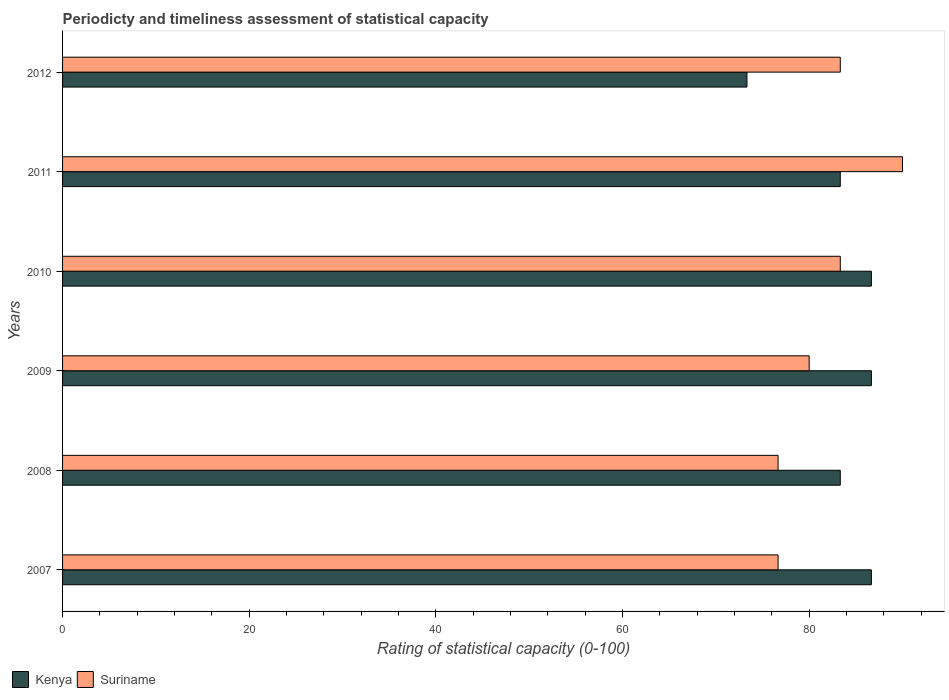How many different coloured bars are there?
Ensure brevity in your answer.  2. How many groups of bars are there?
Your answer should be compact. 6. Are the number of bars per tick equal to the number of legend labels?
Give a very brief answer. Yes. How many bars are there on the 5th tick from the top?
Your response must be concise. 2. In how many cases, is the number of bars for a given year not equal to the number of legend labels?
Your answer should be very brief. 0. What is the rating of statistical capacity in Suriname in 2009?
Your response must be concise. 80. Across all years, what is the maximum rating of statistical capacity in Kenya?
Ensure brevity in your answer.  86.67. Across all years, what is the minimum rating of statistical capacity in Kenya?
Offer a terse response. 73.33. In which year was the rating of statistical capacity in Suriname maximum?
Your answer should be very brief. 2011. What is the total rating of statistical capacity in Suriname in the graph?
Your answer should be very brief. 490. What is the difference between the rating of statistical capacity in Kenya in 2010 and that in 2012?
Keep it short and to the point. 13.33. What is the difference between the rating of statistical capacity in Kenya in 2010 and the rating of statistical capacity in Suriname in 2007?
Ensure brevity in your answer.  10. What is the average rating of statistical capacity in Suriname per year?
Your response must be concise. 81.67. In the year 2012, what is the difference between the rating of statistical capacity in Suriname and rating of statistical capacity in Kenya?
Keep it short and to the point. 10. What is the ratio of the rating of statistical capacity in Kenya in 2009 to that in 2012?
Your response must be concise. 1.18. Is the rating of statistical capacity in Kenya in 2008 less than that in 2011?
Give a very brief answer. No. Is the difference between the rating of statistical capacity in Suriname in 2009 and 2011 greater than the difference between the rating of statistical capacity in Kenya in 2009 and 2011?
Make the answer very short. No. What is the difference between the highest and the second highest rating of statistical capacity in Suriname?
Make the answer very short. 6.67. What is the difference between the highest and the lowest rating of statistical capacity in Kenya?
Provide a short and direct response. 13.33. Is the sum of the rating of statistical capacity in Suriname in 2009 and 2010 greater than the maximum rating of statistical capacity in Kenya across all years?
Provide a succinct answer. Yes. What does the 2nd bar from the top in 2012 represents?
Your response must be concise. Kenya. What does the 2nd bar from the bottom in 2010 represents?
Provide a succinct answer. Suriname. Are all the bars in the graph horizontal?
Offer a terse response. Yes. How many years are there in the graph?
Keep it short and to the point. 6. Does the graph contain any zero values?
Keep it short and to the point. No. Does the graph contain grids?
Keep it short and to the point. No. Where does the legend appear in the graph?
Offer a very short reply. Bottom left. How are the legend labels stacked?
Provide a succinct answer. Horizontal. What is the title of the graph?
Give a very brief answer. Periodicty and timeliness assessment of statistical capacity. Does "Serbia" appear as one of the legend labels in the graph?
Ensure brevity in your answer.  No. What is the label or title of the X-axis?
Give a very brief answer. Rating of statistical capacity (0-100). What is the label or title of the Y-axis?
Your answer should be very brief. Years. What is the Rating of statistical capacity (0-100) of Kenya in 2007?
Ensure brevity in your answer.  86.67. What is the Rating of statistical capacity (0-100) in Suriname in 2007?
Your response must be concise. 76.67. What is the Rating of statistical capacity (0-100) in Kenya in 2008?
Your answer should be very brief. 83.33. What is the Rating of statistical capacity (0-100) of Suriname in 2008?
Offer a terse response. 76.67. What is the Rating of statistical capacity (0-100) of Kenya in 2009?
Provide a short and direct response. 86.67. What is the Rating of statistical capacity (0-100) in Suriname in 2009?
Your answer should be very brief. 80. What is the Rating of statistical capacity (0-100) of Kenya in 2010?
Give a very brief answer. 86.67. What is the Rating of statistical capacity (0-100) in Suriname in 2010?
Make the answer very short. 83.33. What is the Rating of statistical capacity (0-100) of Kenya in 2011?
Provide a short and direct response. 83.33. What is the Rating of statistical capacity (0-100) of Suriname in 2011?
Ensure brevity in your answer.  90. What is the Rating of statistical capacity (0-100) in Kenya in 2012?
Provide a short and direct response. 73.33. What is the Rating of statistical capacity (0-100) in Suriname in 2012?
Give a very brief answer. 83.33. Across all years, what is the maximum Rating of statistical capacity (0-100) in Kenya?
Provide a short and direct response. 86.67. Across all years, what is the minimum Rating of statistical capacity (0-100) of Kenya?
Give a very brief answer. 73.33. Across all years, what is the minimum Rating of statistical capacity (0-100) in Suriname?
Make the answer very short. 76.67. What is the total Rating of statistical capacity (0-100) in Suriname in the graph?
Make the answer very short. 490. What is the difference between the Rating of statistical capacity (0-100) of Suriname in 2007 and that in 2008?
Offer a terse response. 0. What is the difference between the Rating of statistical capacity (0-100) of Kenya in 2007 and that in 2010?
Your answer should be very brief. 0. What is the difference between the Rating of statistical capacity (0-100) of Suriname in 2007 and that in 2010?
Offer a very short reply. -6.67. What is the difference between the Rating of statistical capacity (0-100) in Suriname in 2007 and that in 2011?
Keep it short and to the point. -13.33. What is the difference between the Rating of statistical capacity (0-100) of Kenya in 2007 and that in 2012?
Provide a succinct answer. 13.33. What is the difference between the Rating of statistical capacity (0-100) of Suriname in 2007 and that in 2012?
Your response must be concise. -6.67. What is the difference between the Rating of statistical capacity (0-100) in Kenya in 2008 and that in 2010?
Your response must be concise. -3.33. What is the difference between the Rating of statistical capacity (0-100) of Suriname in 2008 and that in 2010?
Keep it short and to the point. -6.67. What is the difference between the Rating of statistical capacity (0-100) in Suriname in 2008 and that in 2011?
Your response must be concise. -13.33. What is the difference between the Rating of statistical capacity (0-100) in Suriname in 2008 and that in 2012?
Your answer should be compact. -6.67. What is the difference between the Rating of statistical capacity (0-100) of Suriname in 2009 and that in 2010?
Your answer should be very brief. -3.33. What is the difference between the Rating of statistical capacity (0-100) of Suriname in 2009 and that in 2011?
Provide a short and direct response. -10. What is the difference between the Rating of statistical capacity (0-100) in Kenya in 2009 and that in 2012?
Ensure brevity in your answer.  13.33. What is the difference between the Rating of statistical capacity (0-100) in Suriname in 2009 and that in 2012?
Offer a very short reply. -3.33. What is the difference between the Rating of statistical capacity (0-100) in Kenya in 2010 and that in 2011?
Make the answer very short. 3.33. What is the difference between the Rating of statistical capacity (0-100) of Suriname in 2010 and that in 2011?
Keep it short and to the point. -6.67. What is the difference between the Rating of statistical capacity (0-100) of Kenya in 2010 and that in 2012?
Provide a short and direct response. 13.33. What is the difference between the Rating of statistical capacity (0-100) of Suriname in 2011 and that in 2012?
Provide a succinct answer. 6.67. What is the difference between the Rating of statistical capacity (0-100) of Kenya in 2007 and the Rating of statistical capacity (0-100) of Suriname in 2008?
Keep it short and to the point. 10. What is the difference between the Rating of statistical capacity (0-100) in Kenya in 2007 and the Rating of statistical capacity (0-100) in Suriname in 2009?
Provide a succinct answer. 6.67. What is the difference between the Rating of statistical capacity (0-100) of Kenya in 2007 and the Rating of statistical capacity (0-100) of Suriname in 2010?
Ensure brevity in your answer.  3.33. What is the difference between the Rating of statistical capacity (0-100) of Kenya in 2007 and the Rating of statistical capacity (0-100) of Suriname in 2011?
Your response must be concise. -3.33. What is the difference between the Rating of statistical capacity (0-100) of Kenya in 2008 and the Rating of statistical capacity (0-100) of Suriname in 2009?
Offer a terse response. 3.33. What is the difference between the Rating of statistical capacity (0-100) of Kenya in 2008 and the Rating of statistical capacity (0-100) of Suriname in 2010?
Your answer should be very brief. 0. What is the difference between the Rating of statistical capacity (0-100) of Kenya in 2008 and the Rating of statistical capacity (0-100) of Suriname in 2011?
Offer a very short reply. -6.67. What is the difference between the Rating of statistical capacity (0-100) of Kenya in 2008 and the Rating of statistical capacity (0-100) of Suriname in 2012?
Your answer should be very brief. 0. What is the difference between the Rating of statistical capacity (0-100) of Kenya in 2009 and the Rating of statistical capacity (0-100) of Suriname in 2010?
Offer a terse response. 3.33. What is the difference between the Rating of statistical capacity (0-100) in Kenya in 2010 and the Rating of statistical capacity (0-100) in Suriname in 2012?
Provide a short and direct response. 3.33. What is the difference between the Rating of statistical capacity (0-100) in Kenya in 2011 and the Rating of statistical capacity (0-100) in Suriname in 2012?
Offer a very short reply. 0. What is the average Rating of statistical capacity (0-100) of Kenya per year?
Keep it short and to the point. 83.33. What is the average Rating of statistical capacity (0-100) of Suriname per year?
Offer a terse response. 81.67. In the year 2007, what is the difference between the Rating of statistical capacity (0-100) in Kenya and Rating of statistical capacity (0-100) in Suriname?
Your answer should be compact. 10. In the year 2009, what is the difference between the Rating of statistical capacity (0-100) in Kenya and Rating of statistical capacity (0-100) in Suriname?
Offer a very short reply. 6.67. In the year 2010, what is the difference between the Rating of statistical capacity (0-100) in Kenya and Rating of statistical capacity (0-100) in Suriname?
Offer a very short reply. 3.33. In the year 2011, what is the difference between the Rating of statistical capacity (0-100) in Kenya and Rating of statistical capacity (0-100) in Suriname?
Give a very brief answer. -6.67. In the year 2012, what is the difference between the Rating of statistical capacity (0-100) of Kenya and Rating of statistical capacity (0-100) of Suriname?
Your answer should be very brief. -10. What is the ratio of the Rating of statistical capacity (0-100) in Suriname in 2007 to that in 2008?
Your answer should be compact. 1. What is the ratio of the Rating of statistical capacity (0-100) in Suriname in 2007 to that in 2009?
Make the answer very short. 0.96. What is the ratio of the Rating of statistical capacity (0-100) of Suriname in 2007 to that in 2011?
Your response must be concise. 0.85. What is the ratio of the Rating of statistical capacity (0-100) of Kenya in 2007 to that in 2012?
Offer a terse response. 1.18. What is the ratio of the Rating of statistical capacity (0-100) of Suriname in 2007 to that in 2012?
Provide a short and direct response. 0.92. What is the ratio of the Rating of statistical capacity (0-100) of Kenya in 2008 to that in 2009?
Provide a short and direct response. 0.96. What is the ratio of the Rating of statistical capacity (0-100) in Suriname in 2008 to that in 2009?
Keep it short and to the point. 0.96. What is the ratio of the Rating of statistical capacity (0-100) in Kenya in 2008 to that in 2010?
Make the answer very short. 0.96. What is the ratio of the Rating of statistical capacity (0-100) in Suriname in 2008 to that in 2011?
Provide a succinct answer. 0.85. What is the ratio of the Rating of statistical capacity (0-100) in Kenya in 2008 to that in 2012?
Your answer should be compact. 1.14. What is the ratio of the Rating of statistical capacity (0-100) of Suriname in 2009 to that in 2011?
Your answer should be very brief. 0.89. What is the ratio of the Rating of statistical capacity (0-100) in Kenya in 2009 to that in 2012?
Your answer should be very brief. 1.18. What is the ratio of the Rating of statistical capacity (0-100) in Suriname in 2010 to that in 2011?
Your response must be concise. 0.93. What is the ratio of the Rating of statistical capacity (0-100) of Kenya in 2010 to that in 2012?
Provide a short and direct response. 1.18. What is the ratio of the Rating of statistical capacity (0-100) of Suriname in 2010 to that in 2012?
Make the answer very short. 1. What is the ratio of the Rating of statistical capacity (0-100) of Kenya in 2011 to that in 2012?
Ensure brevity in your answer.  1.14. What is the difference between the highest and the second highest Rating of statistical capacity (0-100) of Suriname?
Ensure brevity in your answer.  6.67. What is the difference between the highest and the lowest Rating of statistical capacity (0-100) in Kenya?
Make the answer very short. 13.33. What is the difference between the highest and the lowest Rating of statistical capacity (0-100) in Suriname?
Offer a very short reply. 13.33. 